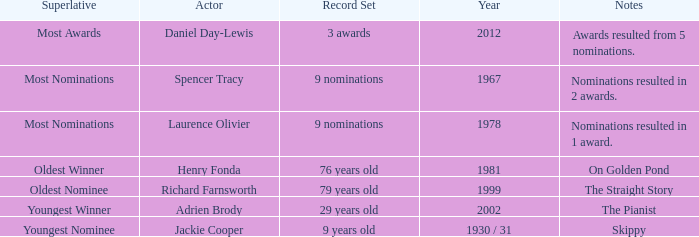What actor won in 1978? Laurence Olivier. 